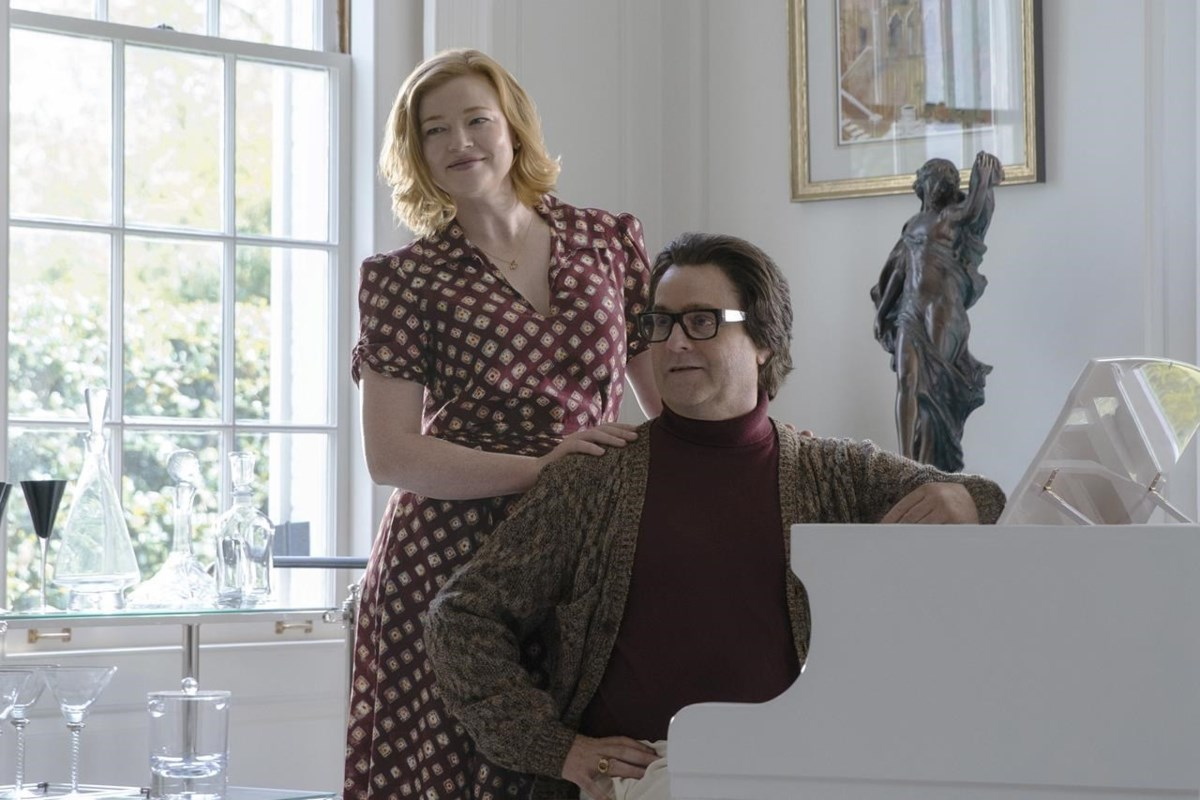Can you describe the scene depicted in this image? Certainly! The image captures a tender moment between two individuals inside a well-lit, elegant room. One person is seated at a grand white piano, their mood appears joyful, indicated by their smile and relaxed posture. They are dressed in a red sweater and a cozy, patterned brown cardigan. The other person stands behind, gently placing a hand on their shoulder, and they share a warm look. This setting is enhanced by a large window that floods the room with natural light, white curtains that add a touch of sophistication, and a beautiful statue of a woman on a pedestal which adds to the overall decor. 